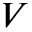Convert formula to latex. <formula><loc_0><loc_0><loc_500><loc_500>V</formula> 